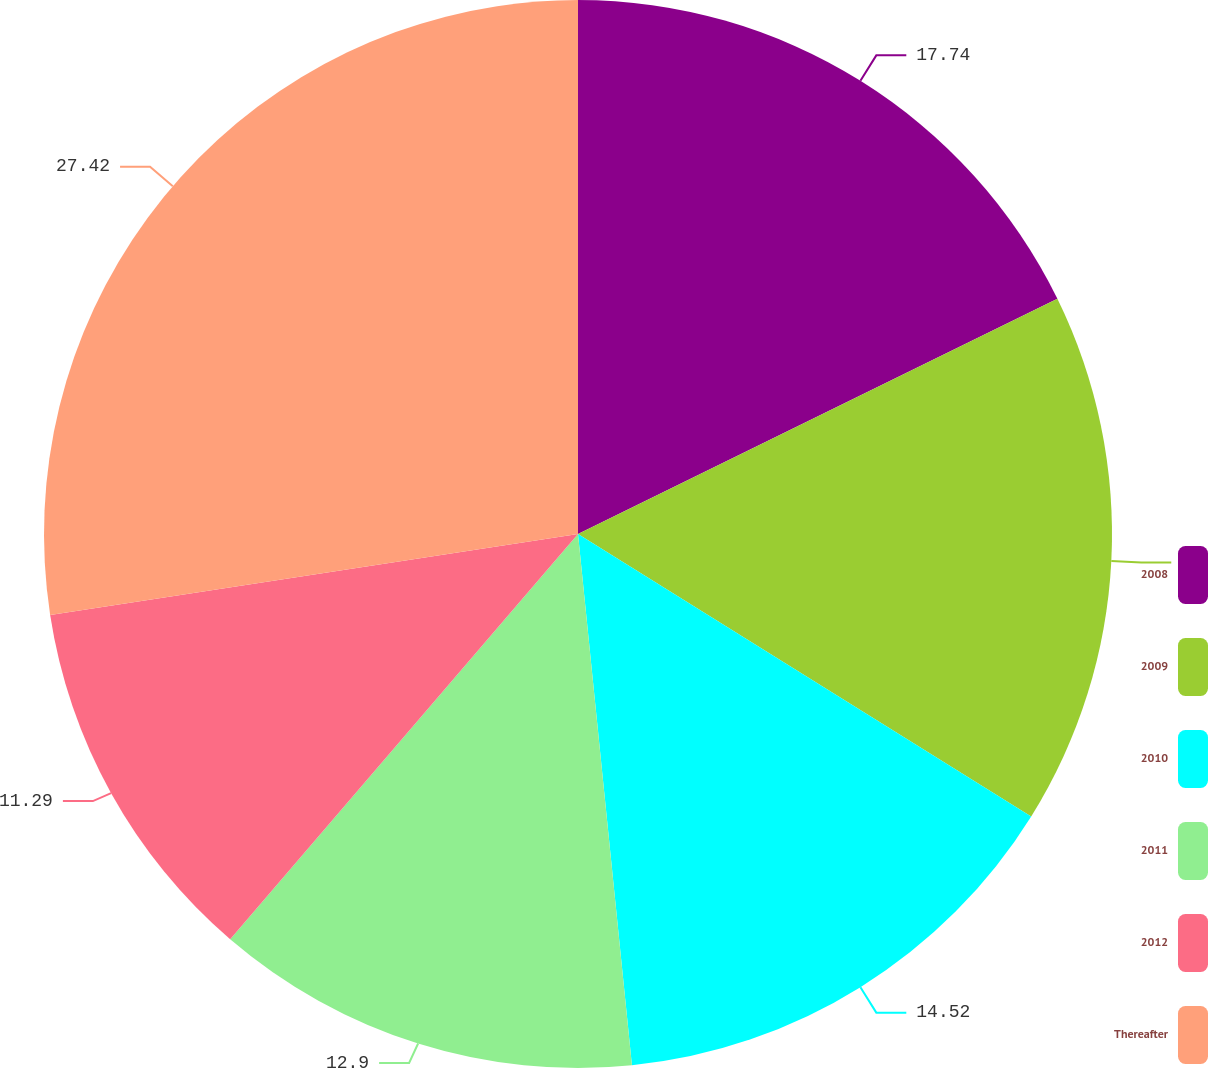Convert chart. <chart><loc_0><loc_0><loc_500><loc_500><pie_chart><fcel>2008<fcel>2009<fcel>2010<fcel>2011<fcel>2012<fcel>Thereafter<nl><fcel>17.74%<fcel>16.13%<fcel>14.52%<fcel>12.9%<fcel>11.29%<fcel>27.42%<nl></chart> 